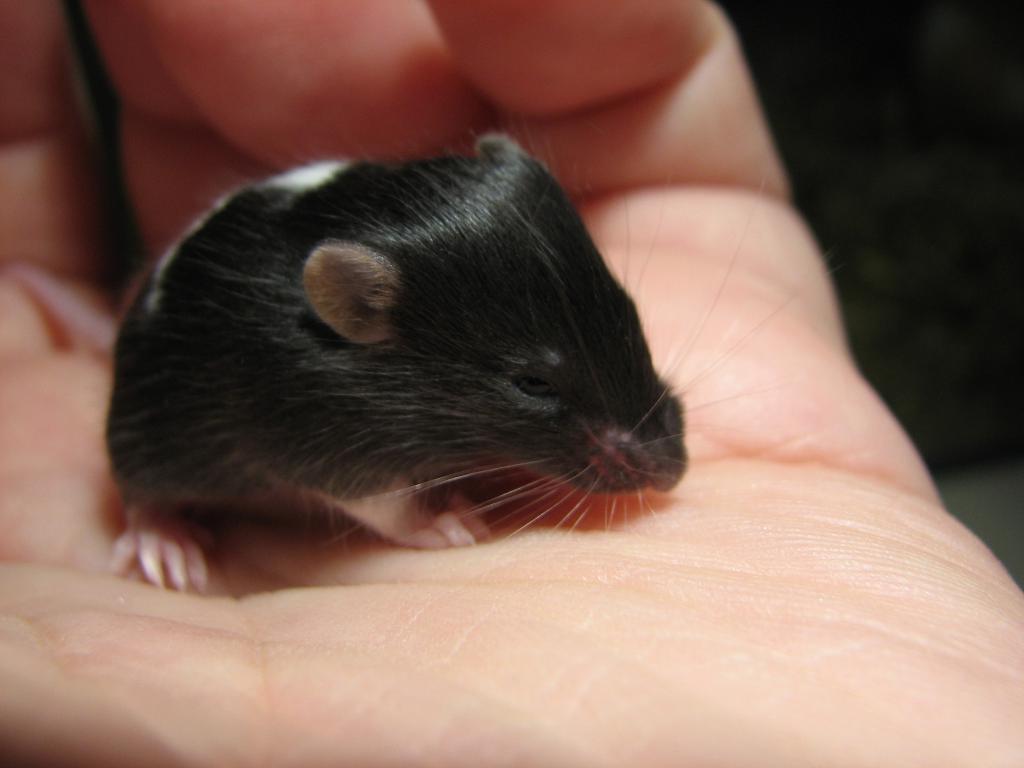Please provide a concise description of this image. In this picture I can see a hamster in the human hand. 